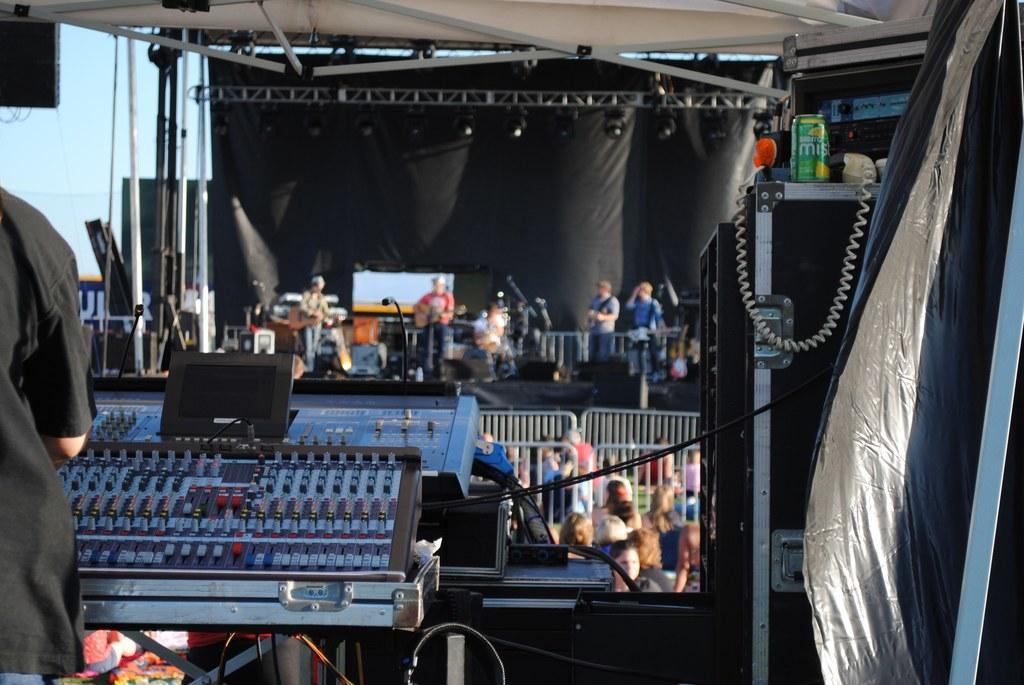Please provide a concise description of this image. In the picture we can see a person standing with black color shirt and operating music machine and beside him we can see a stand on it, we can see a tin and some wire and behind the music machine we can see many people are standing and in front of them, we can see railing and behind it, we can see a stage with some people giving a musical performance holding some musical instruments and behind them we can see a black color curtain and to the ceiling we can see some lights and beside it we can see a part of sky. 